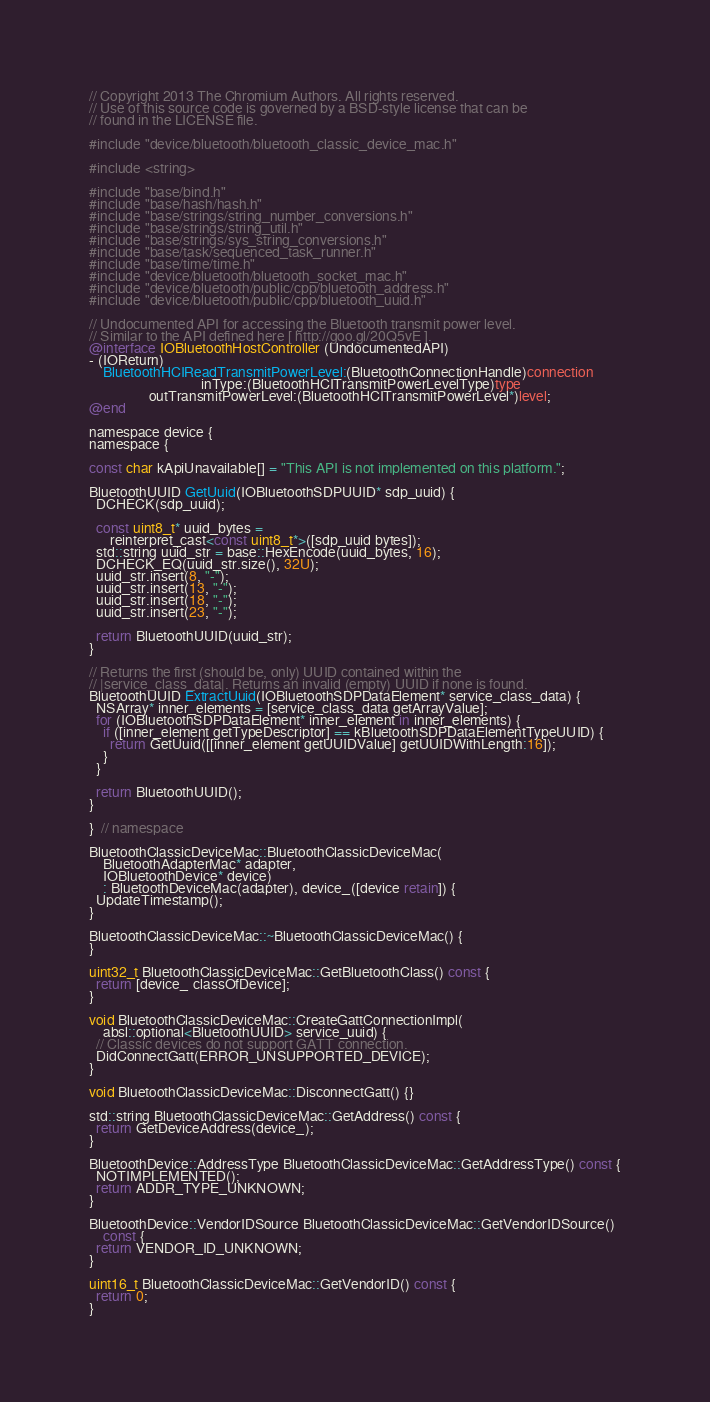<code> <loc_0><loc_0><loc_500><loc_500><_ObjectiveC_>// Copyright 2013 The Chromium Authors. All rights reserved.
// Use of this source code is governed by a BSD-style license that can be
// found in the LICENSE file.

#include "device/bluetooth/bluetooth_classic_device_mac.h"

#include <string>

#include "base/bind.h"
#include "base/hash/hash.h"
#include "base/strings/string_number_conversions.h"
#include "base/strings/string_util.h"
#include "base/strings/sys_string_conversions.h"
#include "base/task/sequenced_task_runner.h"
#include "base/time/time.h"
#include "device/bluetooth/bluetooth_socket_mac.h"
#include "device/bluetooth/public/cpp/bluetooth_address.h"
#include "device/bluetooth/public/cpp/bluetooth_uuid.h"

// Undocumented API for accessing the Bluetooth transmit power level.
// Similar to the API defined here [ http://goo.gl/20Q5vE ].
@interface IOBluetoothHostController (UndocumentedAPI)
- (IOReturn)
    BluetoothHCIReadTransmitPowerLevel:(BluetoothConnectionHandle)connection
                                inType:(BluetoothHCITransmitPowerLevelType)type
                 outTransmitPowerLevel:(BluetoothHCITransmitPowerLevel*)level;
@end

namespace device {
namespace {

const char kApiUnavailable[] = "This API is not implemented on this platform.";

BluetoothUUID GetUuid(IOBluetoothSDPUUID* sdp_uuid) {
  DCHECK(sdp_uuid);

  const uint8_t* uuid_bytes =
      reinterpret_cast<const uint8_t*>([sdp_uuid bytes]);
  std::string uuid_str = base::HexEncode(uuid_bytes, 16);
  DCHECK_EQ(uuid_str.size(), 32U);
  uuid_str.insert(8, "-");
  uuid_str.insert(13, "-");
  uuid_str.insert(18, "-");
  uuid_str.insert(23, "-");

  return BluetoothUUID(uuid_str);
}

// Returns the first (should be, only) UUID contained within the
// |service_class_data|. Returns an invalid (empty) UUID if none is found.
BluetoothUUID ExtractUuid(IOBluetoothSDPDataElement* service_class_data) {
  NSArray* inner_elements = [service_class_data getArrayValue];
  for (IOBluetoothSDPDataElement* inner_element in inner_elements) {
    if ([inner_element getTypeDescriptor] == kBluetoothSDPDataElementTypeUUID) {
      return GetUuid([[inner_element getUUIDValue] getUUIDWithLength:16]);
    }
  }

  return BluetoothUUID();
}

}  // namespace

BluetoothClassicDeviceMac::BluetoothClassicDeviceMac(
    BluetoothAdapterMac* adapter,
    IOBluetoothDevice* device)
    : BluetoothDeviceMac(adapter), device_([device retain]) {
  UpdateTimestamp();
}

BluetoothClassicDeviceMac::~BluetoothClassicDeviceMac() {
}

uint32_t BluetoothClassicDeviceMac::GetBluetoothClass() const {
  return [device_ classOfDevice];
}

void BluetoothClassicDeviceMac::CreateGattConnectionImpl(
    absl::optional<BluetoothUUID> service_uuid) {
  // Classic devices do not support GATT connection.
  DidConnectGatt(ERROR_UNSUPPORTED_DEVICE);
}

void BluetoothClassicDeviceMac::DisconnectGatt() {}

std::string BluetoothClassicDeviceMac::GetAddress() const {
  return GetDeviceAddress(device_);
}

BluetoothDevice::AddressType BluetoothClassicDeviceMac::GetAddressType() const {
  NOTIMPLEMENTED();
  return ADDR_TYPE_UNKNOWN;
}

BluetoothDevice::VendorIDSource BluetoothClassicDeviceMac::GetVendorIDSource()
    const {
  return VENDOR_ID_UNKNOWN;
}

uint16_t BluetoothClassicDeviceMac::GetVendorID() const {
  return 0;
}
</code> 